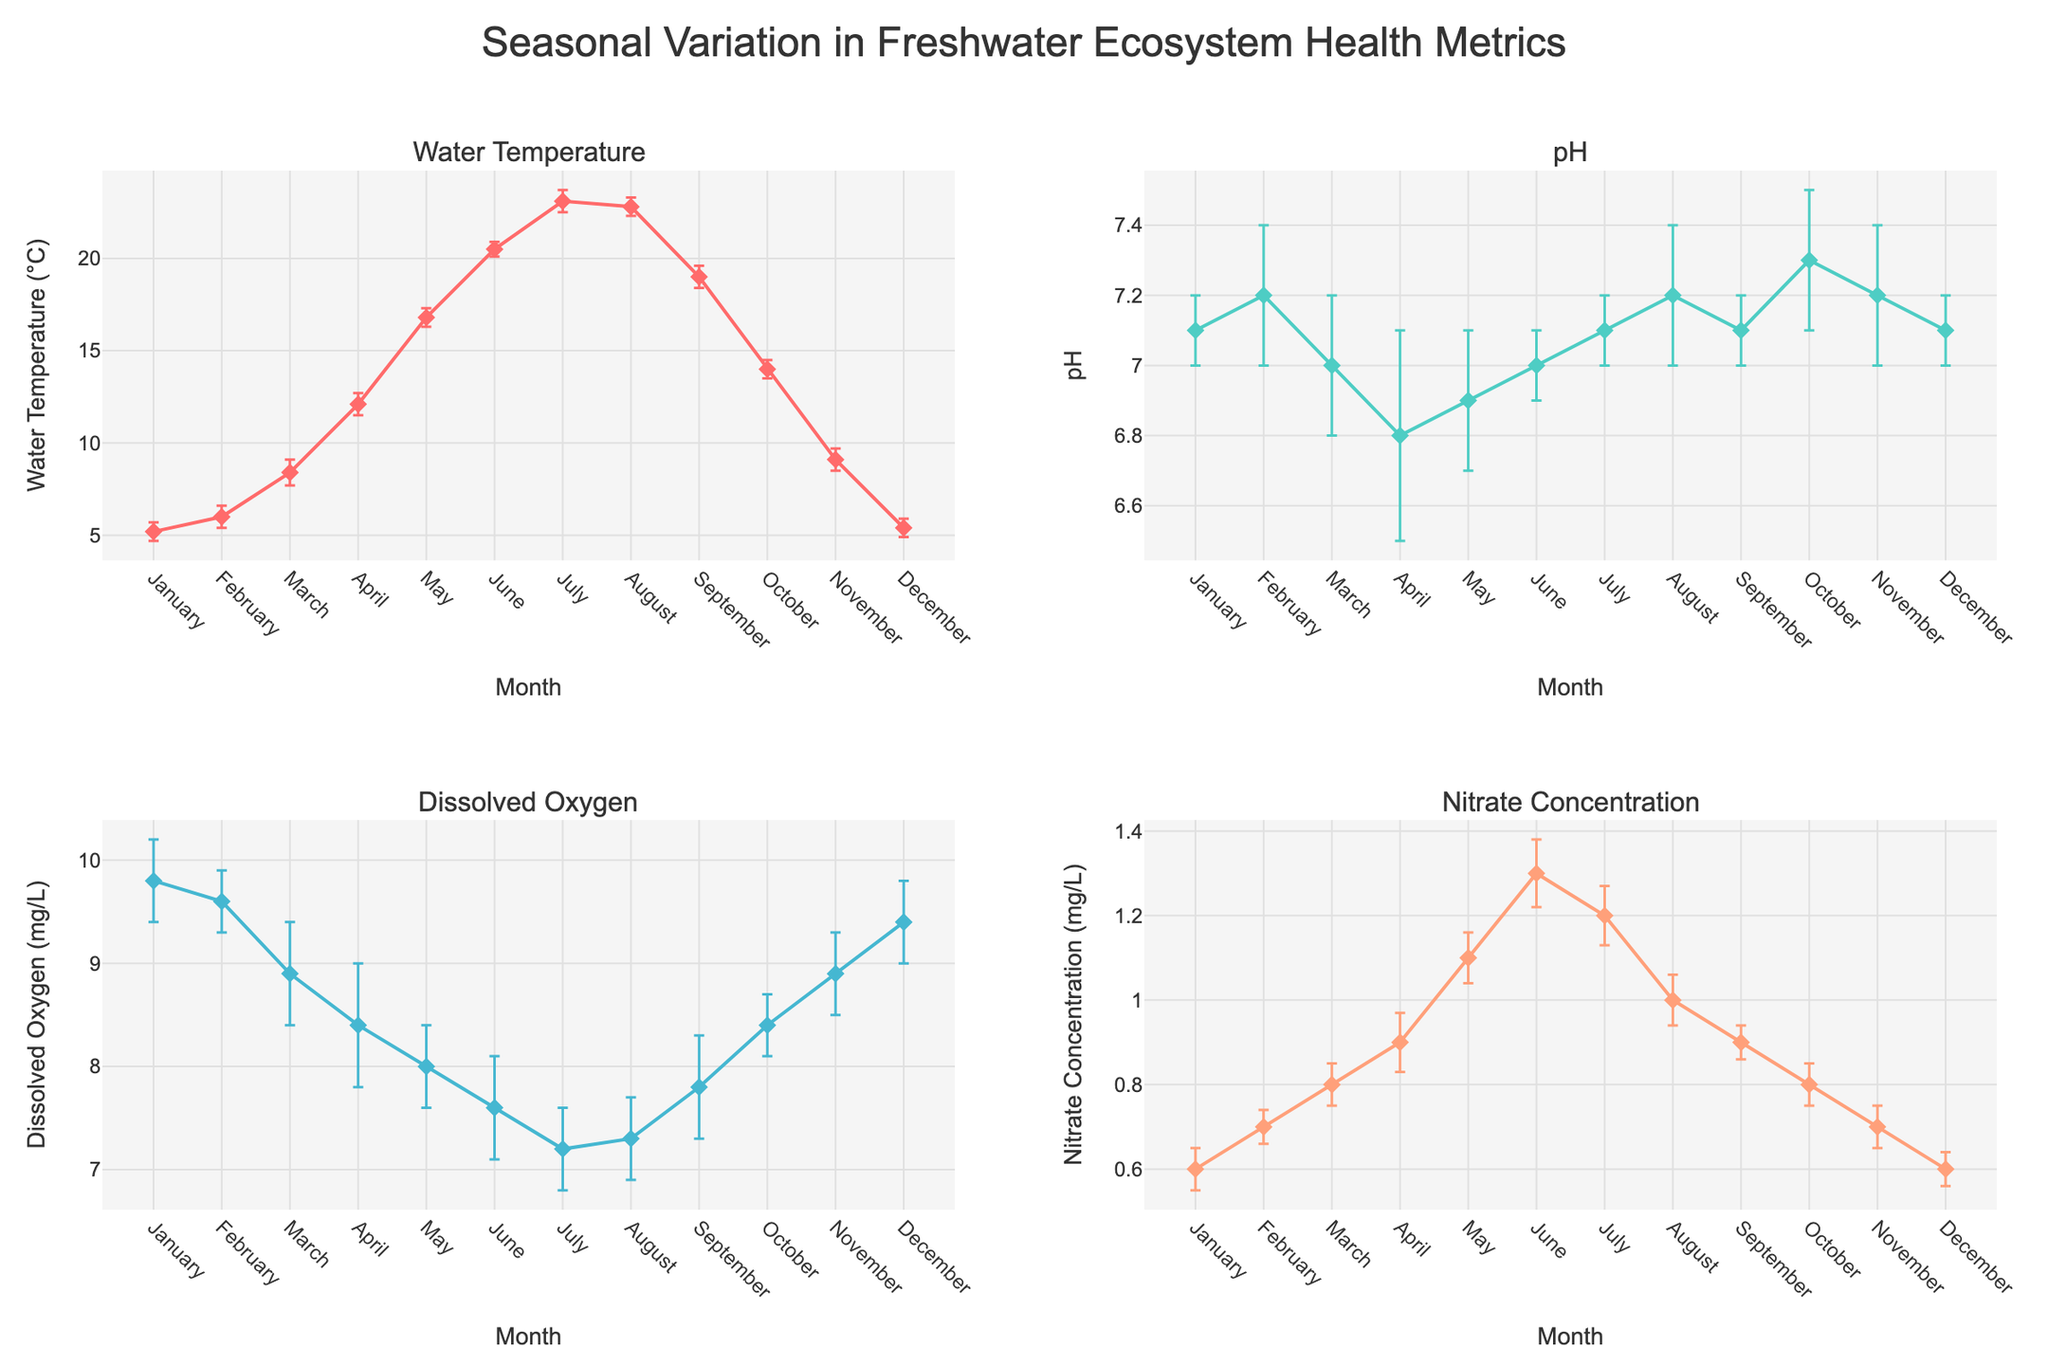What is the average water temperature in June? The average water temperature for June can be found by locating the data point for June and reading the corresponding value for water temperature on the plot.
Answer: 20.5°C During which month is the pH value the highest? By examining the pH values of each month in the respective subplot, the month with the highest pH value can be identified.
Answer: October How does the dissolved oxygen level in January compare to that in July? To compare dissolved oxygen levels, find the averages for January and July in the respective subplot and compare these values.
Answer: January has a higher dissolved oxygen level than July What is the range for nitrate concentration in April? The average nitrate concentration plus and minus the standard deviation gives the range. For April, this would be (0.9 ± 0.07).
Answer: 0.83 to 0.97 mg/L Which metric shows the most variation (largest standard deviation) in the month of March? Check the standard deviation for each metric in March and identify the largest one.
Answer: Dissolved Oxygen (0.5) If we compare the water temperature in March and November, how much does it change? Subtract the average water temperature in November from that in March.
Answer: 8.4 - 9.1 = -0.7°C During which month does the nitrate concentration reach its peak? Identify the highest value for nitrate concentration by scanning through the values in the nitrate concentration subplot.
Answer: June What is the trend of pH values from January to December? By observing the general changes in pH values from January to December, one can describe the trend.
Answer: Mostly stable with some minor fluctuations Which month has the lowest dissolved oxygen level and what is that level? Locate the lowest point in the dissolved oxygen subplot and identify the corresponding month and value.
Answer: July, 7.2 mg/L Is there any month where all four metrics show relatively low variation (small standard deviations)? Check if there is any month where all standard deviations are relatively low across all metrics subplots.
Answer: January 